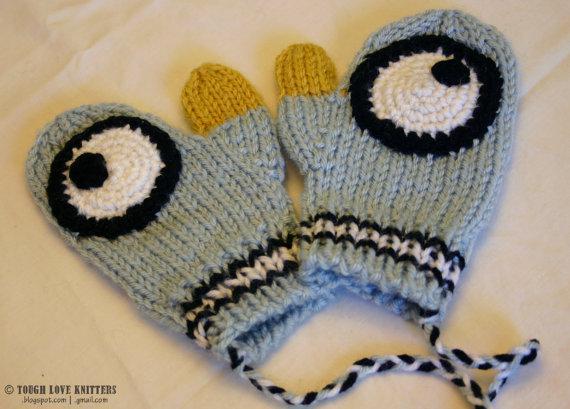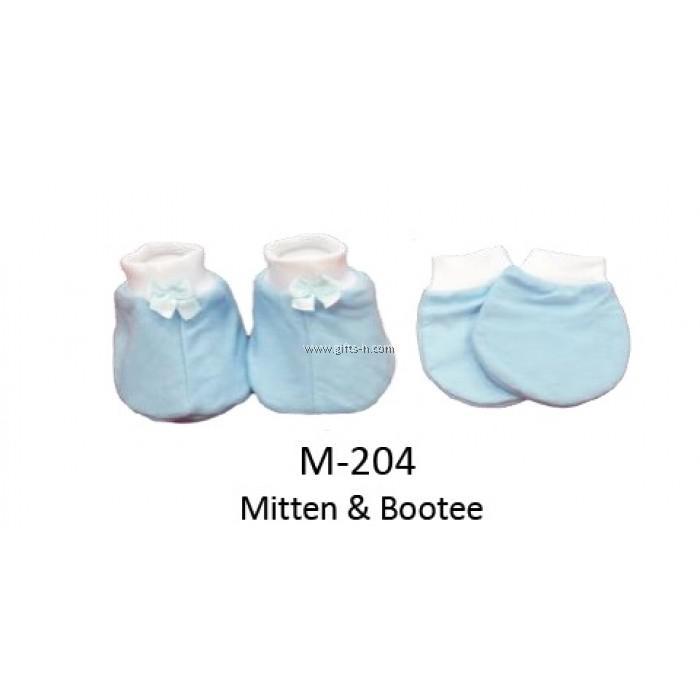The first image is the image on the left, the second image is the image on the right. Given the left and right images, does the statement "The left and right image contains a total of four mittens and two bootees." hold true? Answer yes or no. Yes. The first image is the image on the left, the second image is the image on the right. Assess this claim about the two images: "The combined images include three paired items, and one paired item features black-and-white eye shapes.". Correct or not? Answer yes or no. Yes. 